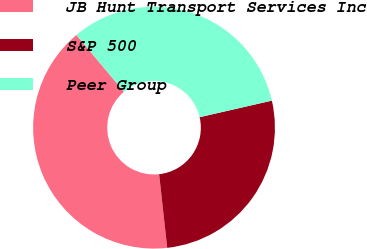Convert chart. <chart><loc_0><loc_0><loc_500><loc_500><pie_chart><fcel>JB Hunt Transport Services Inc<fcel>S&P 500<fcel>Peer Group<nl><fcel>40.65%<fcel>26.85%<fcel>32.5%<nl></chart> 